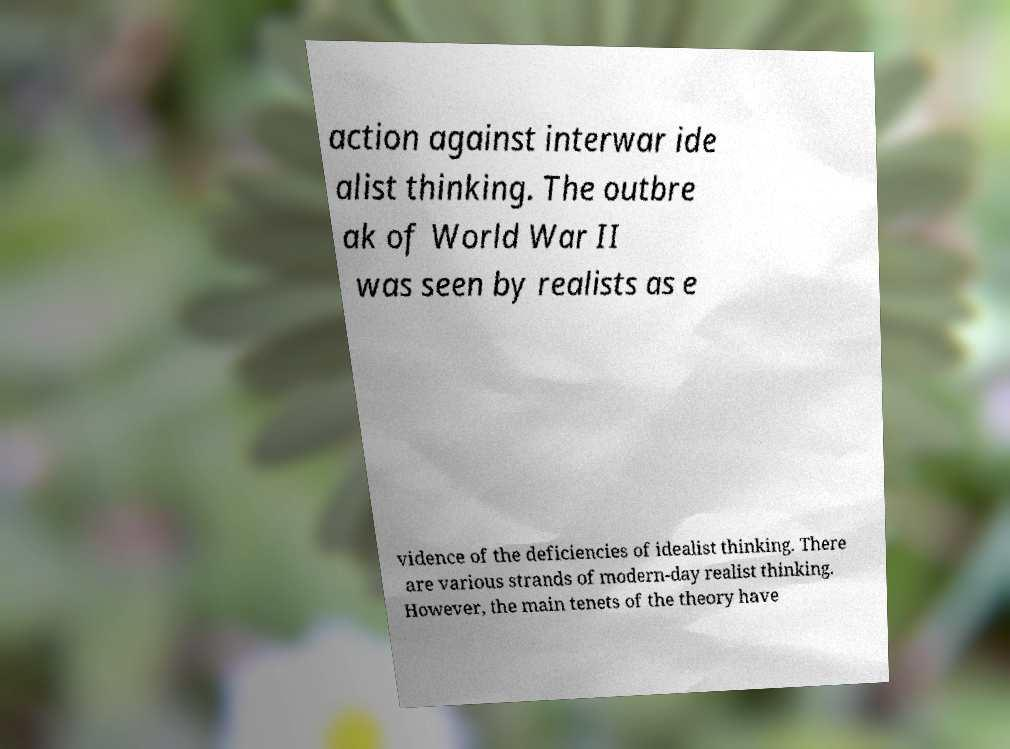Could you explain what are the main tenets of the realist theory mentioned in the text? Of course. Realist theory in international relations is built on several key tenets. One fundamental principle is that the international system is anarchic, meaning there is no overarching authority to enforce rules or norms. States are the primary actors, and they act in their own self-interest, often prioritizing security and power. Realism also posits that conflicts are inevitable due to competition for power and resources. Additionally, realists believe that moral considerations often take a back seat to the pragmatics of power politics. The text in the image seems to be a scholarly interpretation or teaching material summarizing these perspectives. 